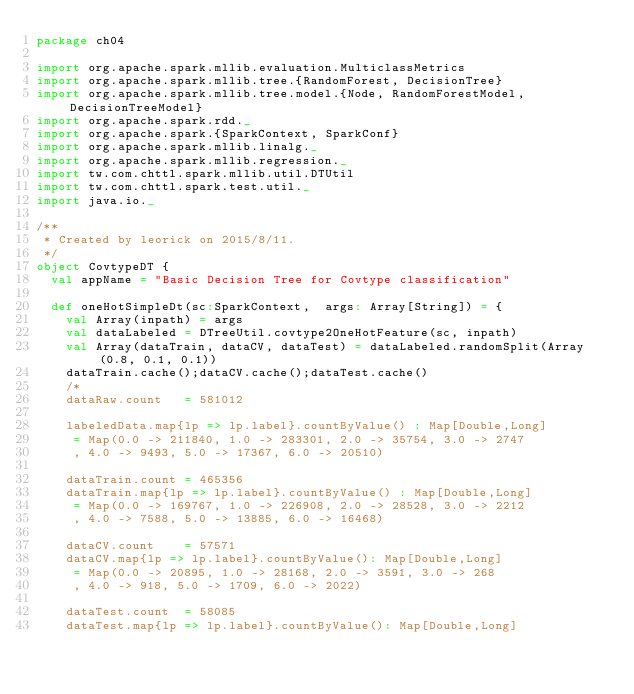Convert code to text. <code><loc_0><loc_0><loc_500><loc_500><_Scala_>package ch04

import org.apache.spark.mllib.evaluation.MulticlassMetrics
import org.apache.spark.mllib.tree.{RandomForest, DecisionTree}
import org.apache.spark.mllib.tree.model.{Node, RandomForestModel, DecisionTreeModel}
import org.apache.spark.rdd._
import org.apache.spark.{SparkContext, SparkConf}
import org.apache.spark.mllib.linalg._
import org.apache.spark.mllib.regression._
import tw.com.chttl.spark.mllib.util.DTUtil
import tw.com.chttl.spark.test.util._
import java.io._

/**
 * Created by leorick on 2015/8/11.
 */
object CovtypeDT {
  val appName = "Basic Decision Tree for Covtype classification"

  def oneHotSimpleDt(sc:SparkContext,  args: Array[String]) = {
    val Array(inpath) = args
    val dataLabeled = DTreeUtil.covtype2OneHotFeature(sc, inpath)
    val Array(dataTrain, dataCV, dataTest) = dataLabeled.randomSplit(Array(0.8, 0.1, 0.1))
    dataTrain.cache();dataCV.cache();dataTest.cache()
    /*
    dataRaw.count   = 581012

    labeledData.map{lp => lp.label}.countByValue() : Map[Double,Long]
     = Map(0.0 -> 211840, 1.0 -> 283301, 2.0 -> 35754, 3.0 -> 2747
     , 4.0 -> 9493, 5.0 -> 17367, 6.0 -> 20510)

    dataTrain.count = 465356
    dataTrain.map{lp => lp.label}.countByValue() : Map[Double,Long]
     = Map(0.0 -> 169767, 1.0 -> 226908, 2.0 -> 28528, 3.0 -> 2212
     , 4.0 -> 7588, 5.0 -> 13885, 6.0 -> 16468)

    dataCV.count    = 57571
    dataCV.map{lp => lp.label}.countByValue(): Map[Double,Long]
     = Map(0.0 -> 20895, 1.0 -> 28168, 2.0 -> 3591, 3.0 -> 268
     , 4.0 -> 918, 5.0 -> 1709, 6.0 -> 2022)

    dataTest.count  = 58085
    dataTest.map{lp => lp.label}.countByValue(): Map[Double,Long]</code> 